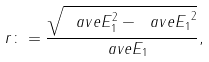<formula> <loc_0><loc_0><loc_500><loc_500>r \colon = \frac { \sqrt { \ a v e { E _ { 1 } ^ { 2 } } - \ a v e { E _ { 1 } } ^ { 2 } } } { \ a v e { E _ { 1 } } } ,</formula> 